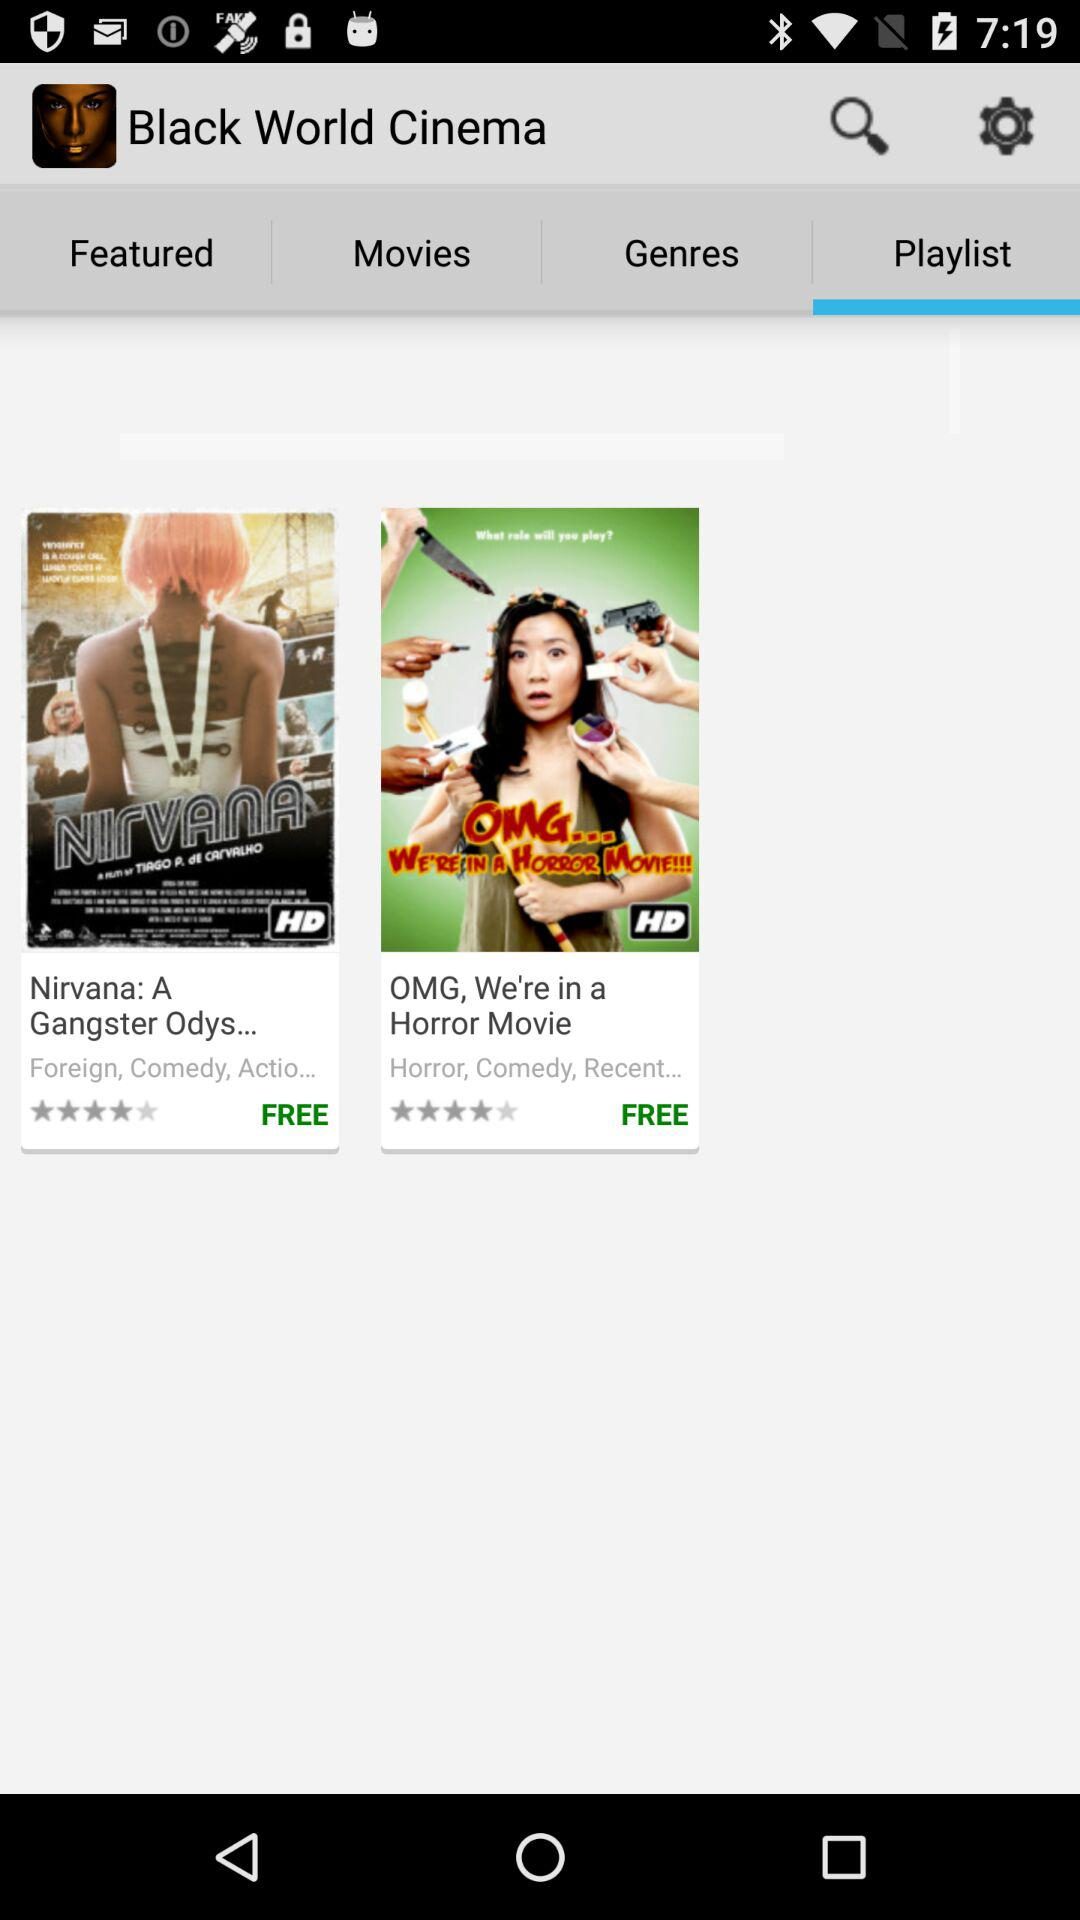What is the application name? The application name is "Black World Cinema". 